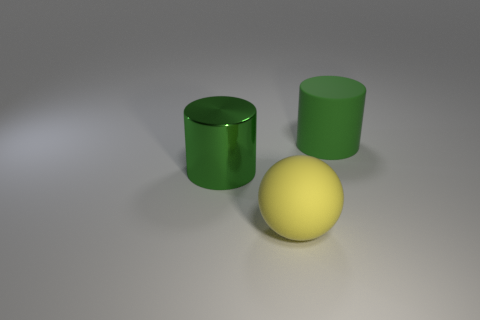Add 1 tiny purple balls. How many objects exist? 4 Subtract all spheres. How many objects are left? 2 Subtract 1 spheres. How many spheres are left? 0 Subtract all red cylinders. Subtract all gray cubes. How many cylinders are left? 2 Subtract all brown shiny blocks. Subtract all big cylinders. How many objects are left? 1 Add 3 large objects. How many large objects are left? 6 Add 3 large yellow rubber balls. How many large yellow rubber balls exist? 4 Subtract 0 gray cylinders. How many objects are left? 3 